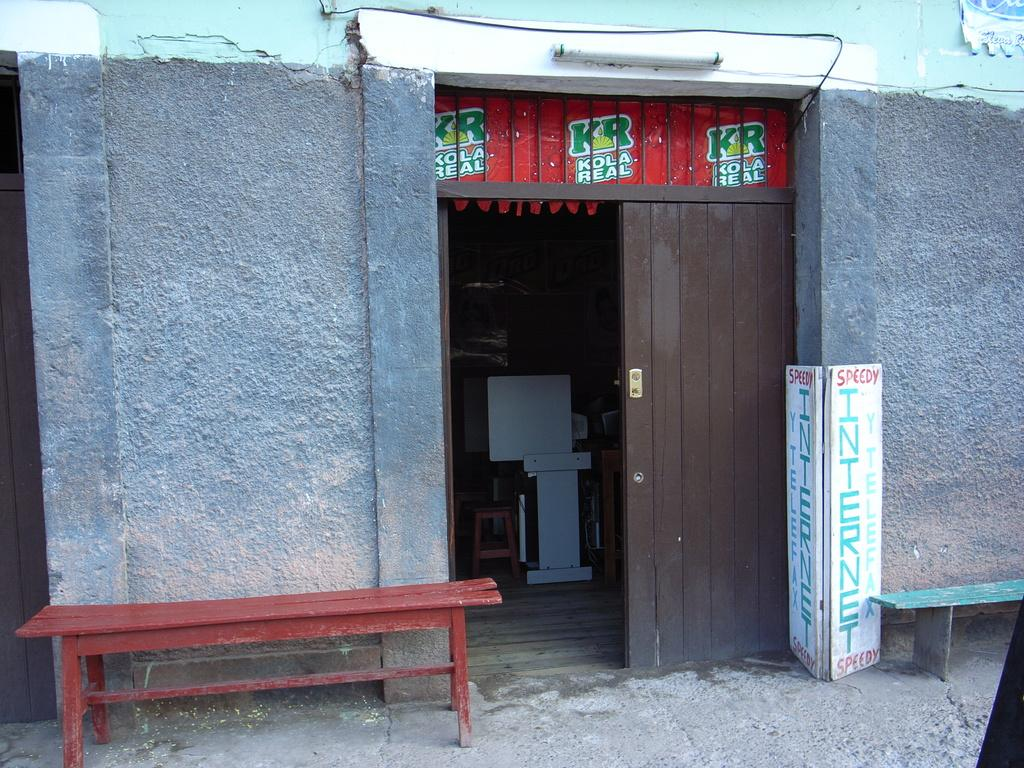What is the main structure in the image? There is a wall in the image. What features are present on the wall? There are doors in the wall. What type of furniture is in front of the wall? There are two benches in front of the wall. What is placed in front of the wall besides the benches? There is a board in front of the wall. What can be seen inside the image? There is a table and a chair visible inside the image. What type of cakes are being taught in the image? There is no indication of any cakes or teaching in the image. What kind of bear is sitting on the chair in the image? There is no bear present in the image. 